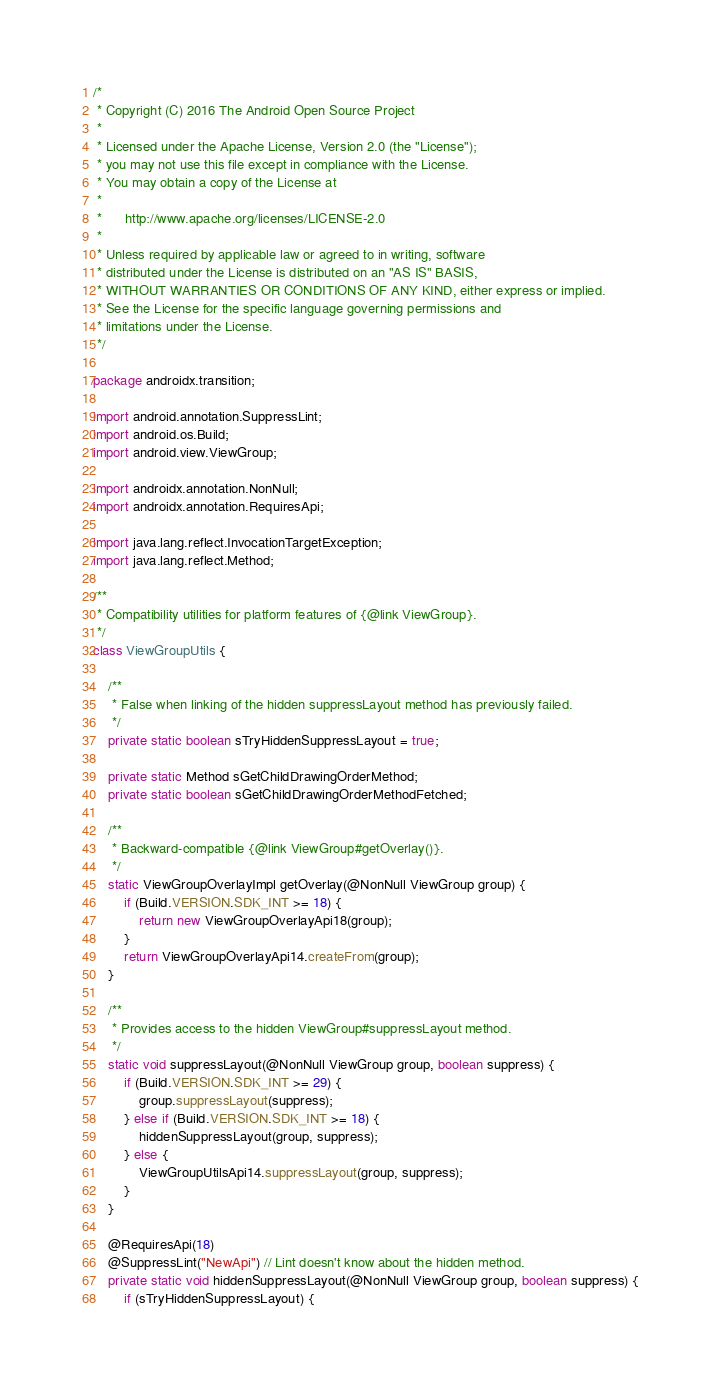Convert code to text. <code><loc_0><loc_0><loc_500><loc_500><_Java_>/*
 * Copyright (C) 2016 The Android Open Source Project
 *
 * Licensed under the Apache License, Version 2.0 (the "License");
 * you may not use this file except in compliance with the License.
 * You may obtain a copy of the License at
 *
 *      http://www.apache.org/licenses/LICENSE-2.0
 *
 * Unless required by applicable law or agreed to in writing, software
 * distributed under the License is distributed on an "AS IS" BASIS,
 * WITHOUT WARRANTIES OR CONDITIONS OF ANY KIND, either express or implied.
 * See the License for the specific language governing permissions and
 * limitations under the License.
 */

package androidx.transition;

import android.annotation.SuppressLint;
import android.os.Build;
import android.view.ViewGroup;

import androidx.annotation.NonNull;
import androidx.annotation.RequiresApi;

import java.lang.reflect.InvocationTargetException;
import java.lang.reflect.Method;

/**
 * Compatibility utilities for platform features of {@link ViewGroup}.
 */
class ViewGroupUtils {

    /**
     * False when linking of the hidden suppressLayout method has previously failed.
     */
    private static boolean sTryHiddenSuppressLayout = true;

    private static Method sGetChildDrawingOrderMethod;
    private static boolean sGetChildDrawingOrderMethodFetched;

    /**
     * Backward-compatible {@link ViewGroup#getOverlay()}.
     */
    static ViewGroupOverlayImpl getOverlay(@NonNull ViewGroup group) {
        if (Build.VERSION.SDK_INT >= 18) {
            return new ViewGroupOverlayApi18(group);
        }
        return ViewGroupOverlayApi14.createFrom(group);
    }

    /**
     * Provides access to the hidden ViewGroup#suppressLayout method.
     */
    static void suppressLayout(@NonNull ViewGroup group, boolean suppress) {
        if (Build.VERSION.SDK_INT >= 29) {
            group.suppressLayout(suppress);
        } else if (Build.VERSION.SDK_INT >= 18) {
            hiddenSuppressLayout(group, suppress);
        } else {
            ViewGroupUtilsApi14.suppressLayout(group, suppress);
        }
    }

    @RequiresApi(18)
    @SuppressLint("NewApi") // Lint doesn't know about the hidden method.
    private static void hiddenSuppressLayout(@NonNull ViewGroup group, boolean suppress) {
        if (sTryHiddenSuppressLayout) {</code> 